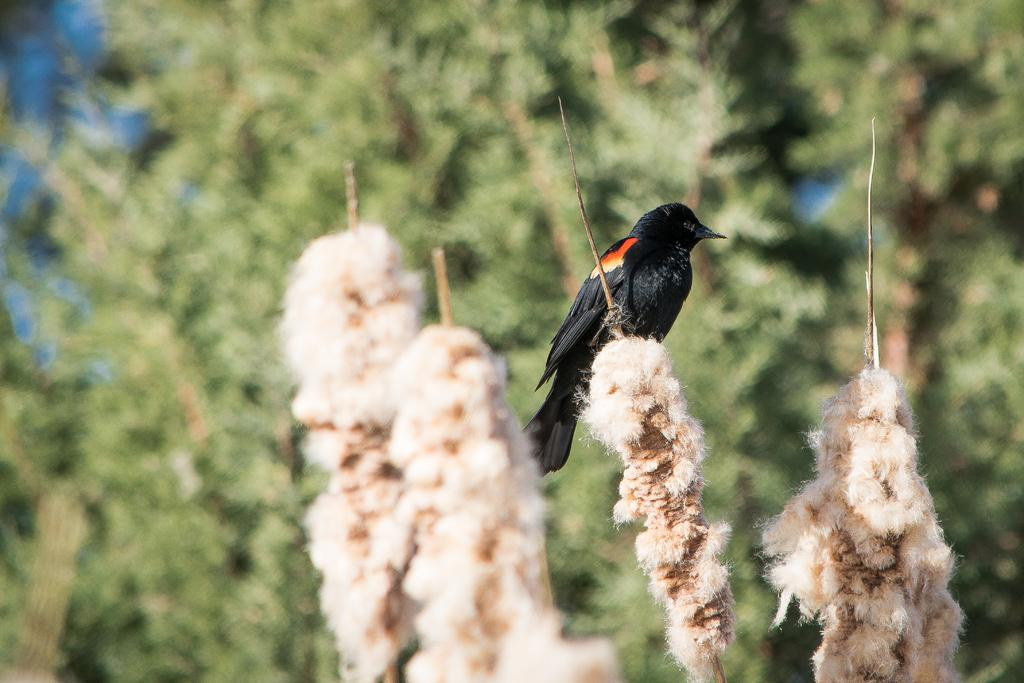What type of animal can be seen in the image? There is a bird in the image. How would you describe the background of the image? The background of the image is blurred. What kind of natural environment is visible in the background? There is greenery in the background of the image. How many pizzas are being served on the seashore in the image? There are no pizzas or seashore present in the image; it features a bird with a blurred background and greenery. What type of spoon is being used by the bird in the image? There is no spoon present in the image; it features a bird with a blurred background and greenery. 